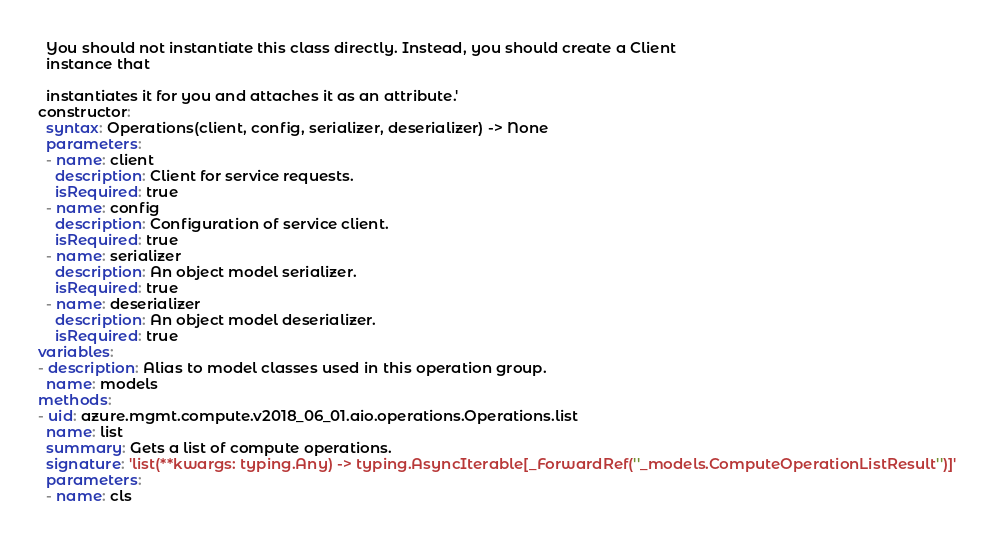<code> <loc_0><loc_0><loc_500><loc_500><_YAML_>

  You should not instantiate this class directly. Instead, you should create a Client
  instance that

  instantiates it for you and attaches it as an attribute.'
constructor:
  syntax: Operations(client, config, serializer, deserializer) -> None
  parameters:
  - name: client
    description: Client for service requests.
    isRequired: true
  - name: config
    description: Configuration of service client.
    isRequired: true
  - name: serializer
    description: An object model serializer.
    isRequired: true
  - name: deserializer
    description: An object model deserializer.
    isRequired: true
variables:
- description: Alias to model classes used in this operation group.
  name: models
methods:
- uid: azure.mgmt.compute.v2018_06_01.aio.operations.Operations.list
  name: list
  summary: Gets a list of compute operations.
  signature: 'list(**kwargs: typing.Any) -> typing.AsyncIterable[_ForwardRef(''_models.ComputeOperationListResult'')]'
  parameters:
  - name: cls</code> 